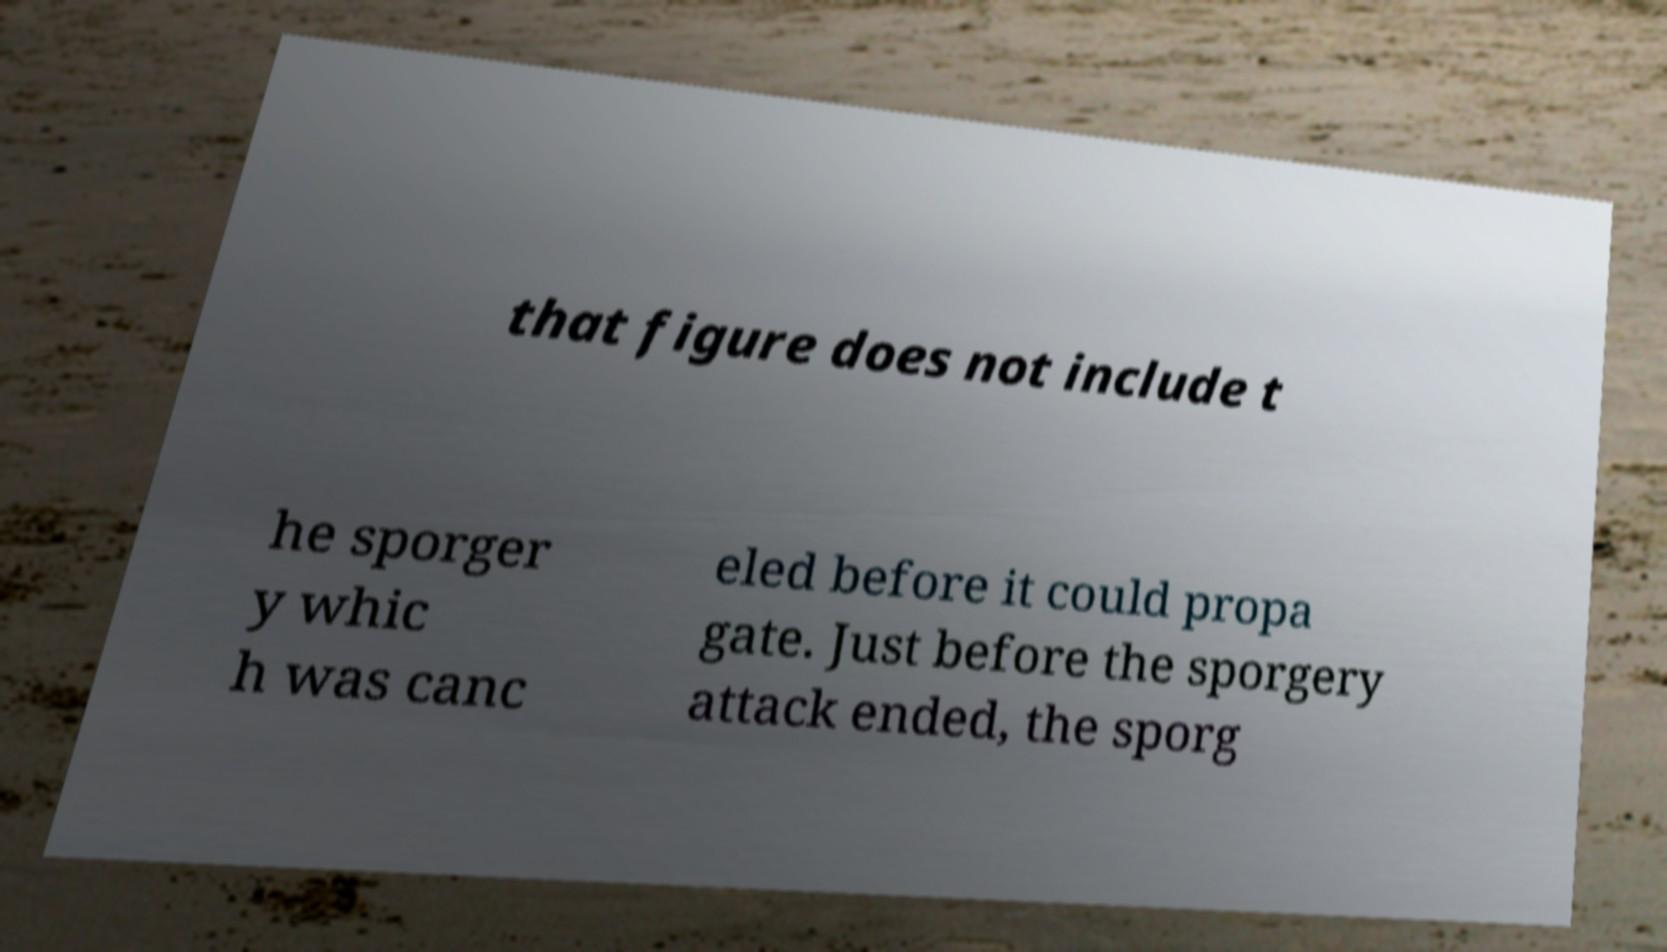There's text embedded in this image that I need extracted. Can you transcribe it verbatim? that figure does not include t he sporger y whic h was canc eled before it could propa gate. Just before the sporgery attack ended, the sporg 